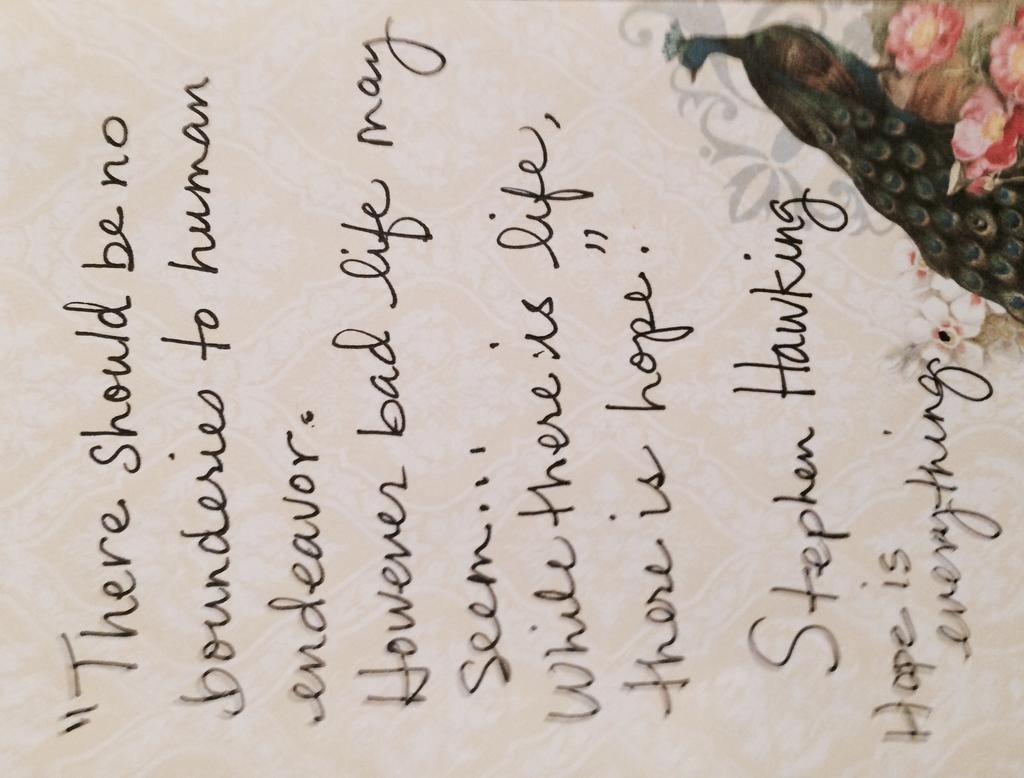What is present on the paper in the image? There is writing on the paper, as well as a peacock image and flower images. Can you describe the writing on the paper? Unfortunately, the specific content of the writing cannot be determined from the image. What type of images are present on the paper? There is a peacock image and flower images on the paper. What type of sleet can be seen falling on the peacock image in the picture? There is no sleet present in the image; it is a paper with writing and images. How does the faucet affect the flower images on the paper? There is no faucet present in the image, so it cannot affect the flower images. 